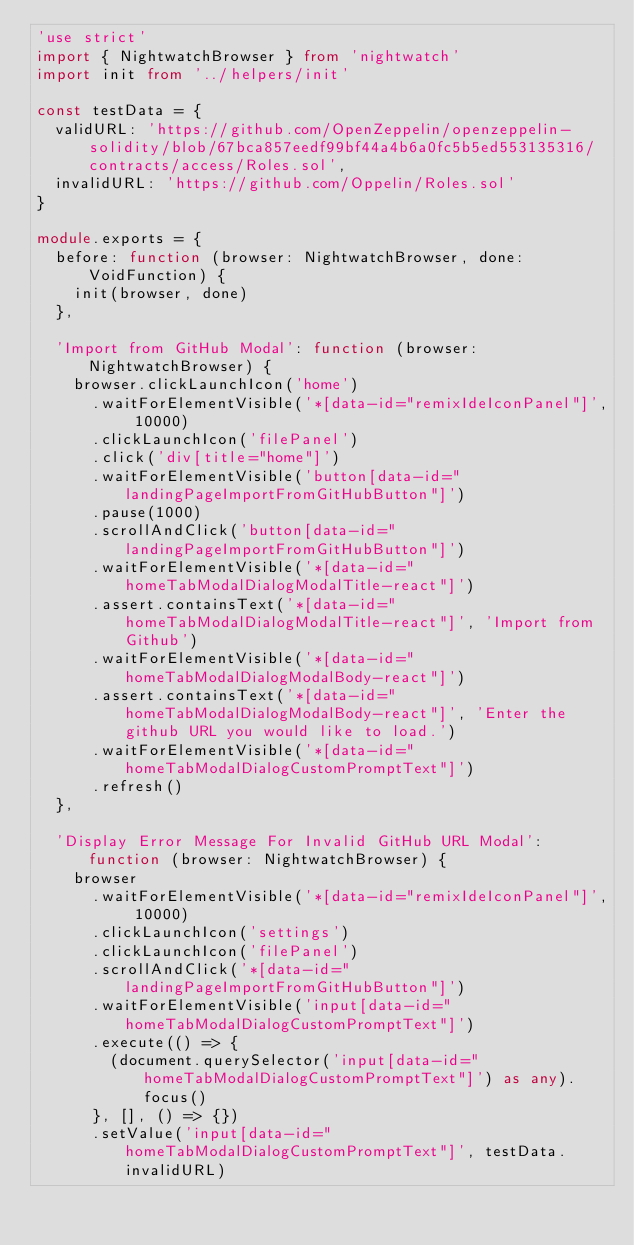<code> <loc_0><loc_0><loc_500><loc_500><_TypeScript_>'use strict'
import { NightwatchBrowser } from 'nightwatch'
import init from '../helpers/init'

const testData = {
  validURL: 'https://github.com/OpenZeppelin/openzeppelin-solidity/blob/67bca857eedf99bf44a4b6a0fc5b5ed553135316/contracts/access/Roles.sol',
  invalidURL: 'https://github.com/Oppelin/Roles.sol'
}

module.exports = {
  before: function (browser: NightwatchBrowser, done: VoidFunction) {
    init(browser, done)
  },

  'Import from GitHub Modal': function (browser: NightwatchBrowser) {
    browser.clickLaunchIcon('home')
      .waitForElementVisible('*[data-id="remixIdeIconPanel"]', 10000)
      .clickLaunchIcon('filePanel')
      .click('div[title="home"]')
      .waitForElementVisible('button[data-id="landingPageImportFromGitHubButton"]')
      .pause(1000)
      .scrollAndClick('button[data-id="landingPageImportFromGitHubButton"]')
      .waitForElementVisible('*[data-id="homeTabModalDialogModalTitle-react"]')
      .assert.containsText('*[data-id="homeTabModalDialogModalTitle-react"]', 'Import from Github')
      .waitForElementVisible('*[data-id="homeTabModalDialogModalBody-react"]')
      .assert.containsText('*[data-id="homeTabModalDialogModalBody-react"]', 'Enter the github URL you would like to load.')
      .waitForElementVisible('*[data-id="homeTabModalDialogCustomPromptText"]')
      .refresh()
  },

  'Display Error Message For Invalid GitHub URL Modal': function (browser: NightwatchBrowser) {
    browser
      .waitForElementVisible('*[data-id="remixIdeIconPanel"]', 10000)
      .clickLaunchIcon('settings')
      .clickLaunchIcon('filePanel')
      .scrollAndClick('*[data-id="landingPageImportFromGitHubButton"]')
      .waitForElementVisible('input[data-id="homeTabModalDialogCustomPromptText"]')
      .execute(() => {
        (document.querySelector('input[data-id="homeTabModalDialogCustomPromptText"]') as any).focus()
      }, [], () => {})
      .setValue('input[data-id="homeTabModalDialogCustomPromptText"]', testData.invalidURL)</code> 